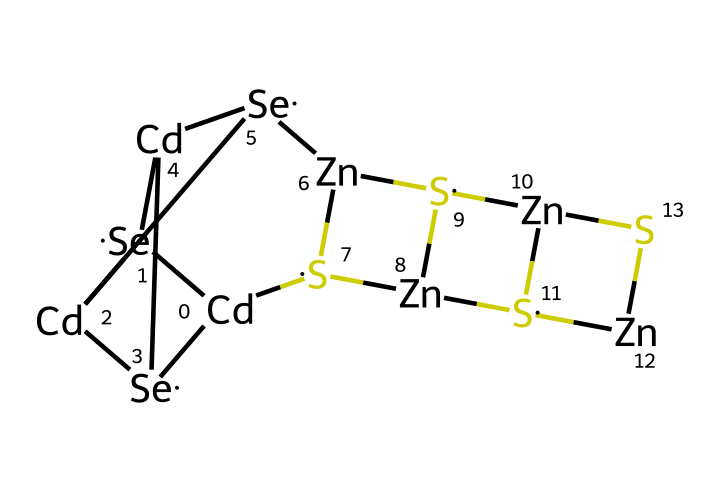What are the primary elements in this quantum dot composition? The SMILES representation shows the presence of cadmium (Cd), selenium (Se), zinc (Zn), and sulfur (S). These elements are explicitly stated in the structure.
Answer: cadmium, selenium, zinc, sulfur How many cadmium atoms are in this structure? By counting the occurrences of 'Cd' in the SMILES representation, we find there are three instances of 'Cd'.
Answer: three What type of chemical structure does this quantum dot represent? Quantum dots are semiconductor nanocrystals, and this specific arrangement of elements indicates a nanocrystalline structure conducive for LEDs.
Answer: semiconductor What is the total number of zinc atoms present in this quantum dot? A direct count of 'Zn' in the SMILES representation shows there are four occurrences of 'Zn'.
Answer: four How many distinct types of atoms are present in this quantum dot structure? The elements identified (Cd, Se, Zn, S) mean there are four distinct types of atoms represented in the structure.
Answer: four What is the role of sulfur in this quantum dot? Sulfur commonly acts as a stabilizing agent in quantum dots and contributes to the overall band gap properties of the semiconductor.
Answer: stabilizing agent How would the arrangement of these atoms affect the quantum dot's electronic properties? The specific arrangement and bonding of cadmium, selenium, zinc, and sulfur influence charge carriers' mobility and energy band structure, which matters for LED functionality.
Answer: affects charge carriers' mobility 